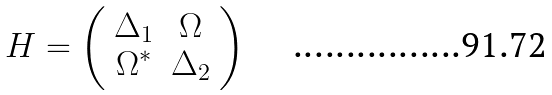<formula> <loc_0><loc_0><loc_500><loc_500>H = \left ( \begin{array} { c c } \Delta _ { 1 } & \Omega \\ \Omega ^ { \ast } & \Delta _ { 2 } \end{array} \right )</formula> 